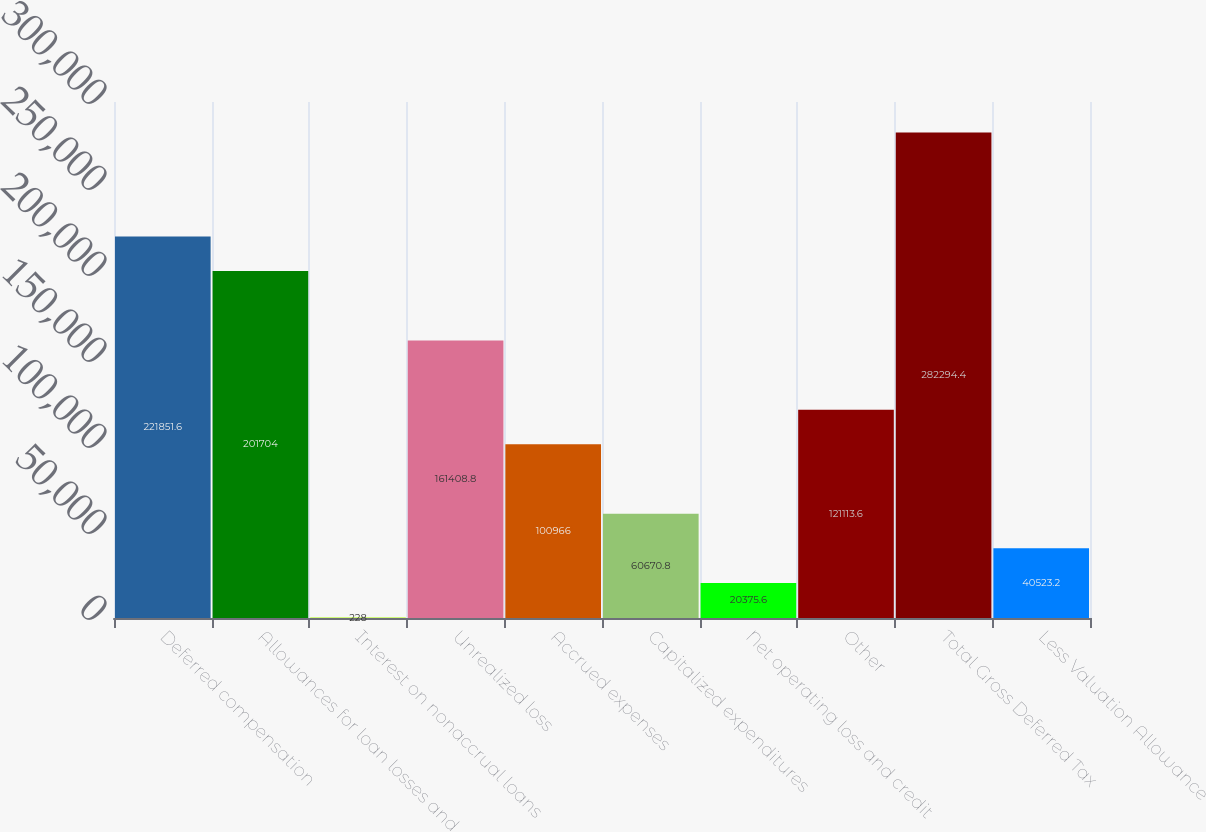Convert chart to OTSL. <chart><loc_0><loc_0><loc_500><loc_500><bar_chart><fcel>Deferred compensation<fcel>Allowances for loan losses and<fcel>Interest on nonaccrual loans<fcel>Unrealized loss<fcel>Accrued expenses<fcel>Capitalized expenditures<fcel>Net operating loss and credit<fcel>Other<fcel>Total Gross Deferred Tax<fcel>Less Valuation Allowance<nl><fcel>221852<fcel>201704<fcel>228<fcel>161409<fcel>100966<fcel>60670.8<fcel>20375.6<fcel>121114<fcel>282294<fcel>40523.2<nl></chart> 